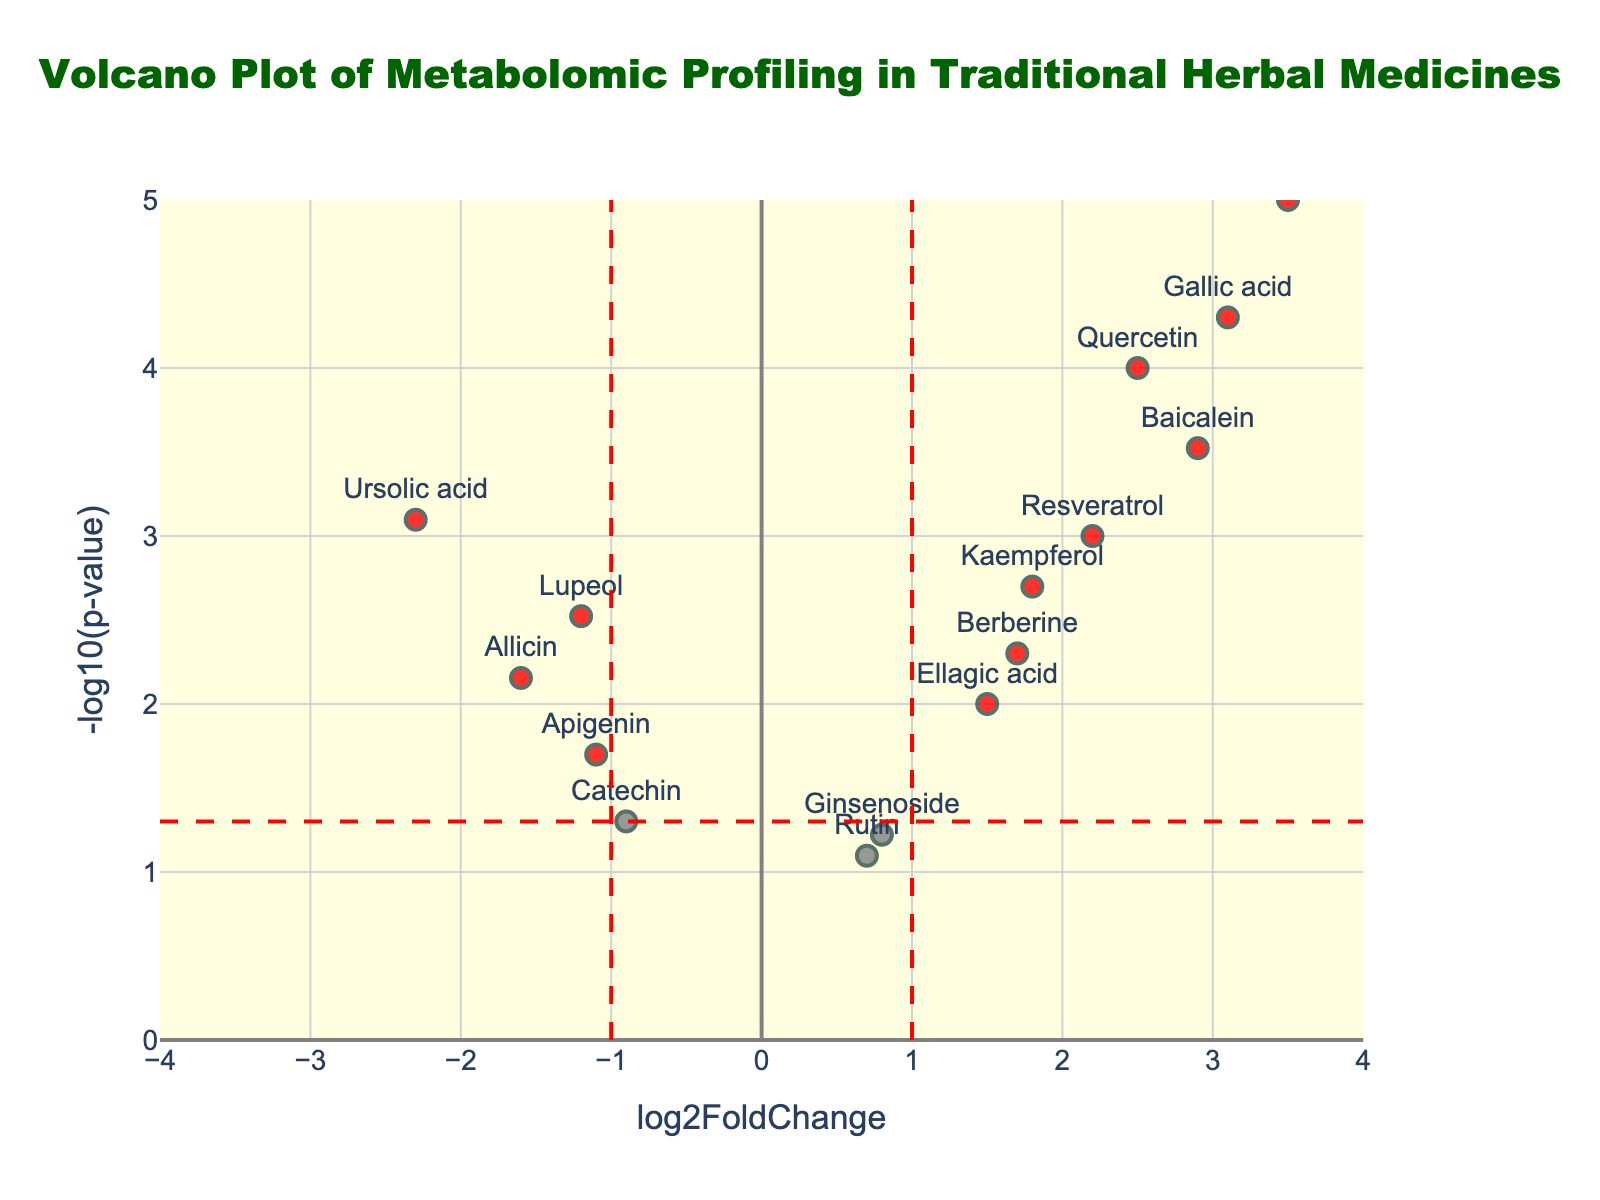What is the title of the plot? The title of the plot is displayed at the top of the figure.
Answer: Volcano Plot of Metabolomic Profiling in Traditional Herbal Medicines What does the x-axis represent? The x-axis represents the log2FoldChange, which is a measure of the change in expression levels between two conditions on a logarithmic scale.
Answer: log2FoldChange Which compound has the highest log2FoldChange? By looking at the compound with the highest x-axis value, we can identify that Curcumin has the highest log2FoldChange.
Answer: Curcumin Which compound has the lowest p-value? The lowest p-value corresponds to the highest -log10(pValue) on the y-axis. Therefore, Curcumin has the lowest p-value.
Answer: Curcumin How many compounds have a log2FoldChange greater than 1 and a p-value less than 0.05? Compounds with a log2FoldChange greater than 1 are those to the right of the vertical red threshold line at x=1, and those with a p-value less than 0.05 are above the horizontal red threshold line. We count the compounds meeting both criteria.
Answer: 7 Are there any compounds with a significant negative log2FoldChange? A significant negative log2FoldChange would mean values less than -1 on the x-axis and above the p-value threshold on the y-axis. Compounds here are Allicin, Apigenin, Ursolic acid, and Lupeol.
Answer: Yes Between Baicalein and Gallic acid, which compound has a higher -log10(p-value)? By comparing their y-axis values, we can determine that Gallic acid has a higher -log10(pValue) than Baicalein.
Answer: Gallic acid Which compounds fall into the 'blue' category and what constitutes this category? Compounds in the 'blue' category are those with an absolute log2FoldChange less than or equal to 1 and a p-value less than 0.05. The compounds are Rutin and Ginsenoside.
Answer: Rutin, Ginsenoside How many data points are there in total? The total number of data points can be found by counting all the compounds listed in the plot.
Answer: 15 Which compound has both a high log2FoldChange and a high -log10(p-value)? A high log2FoldChange means values much greater than 1 on the x-axis and a high -log10(pValue) means high values on the y-axis. Curcumin satisfies both conditions.
Answer: Curcumin 